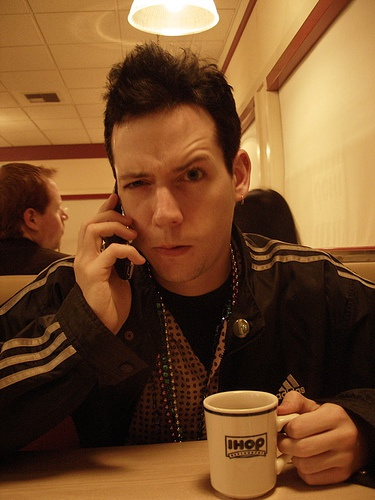Describe the objects in this image and their specific colors. I can see people in brown, black, and maroon tones, dining table in brown, olive, black, and maroon tones, cup in brown, olive, tan, and maroon tones, people in brown, black, and maroon tones, and people in brown, black, and maroon tones in this image. 